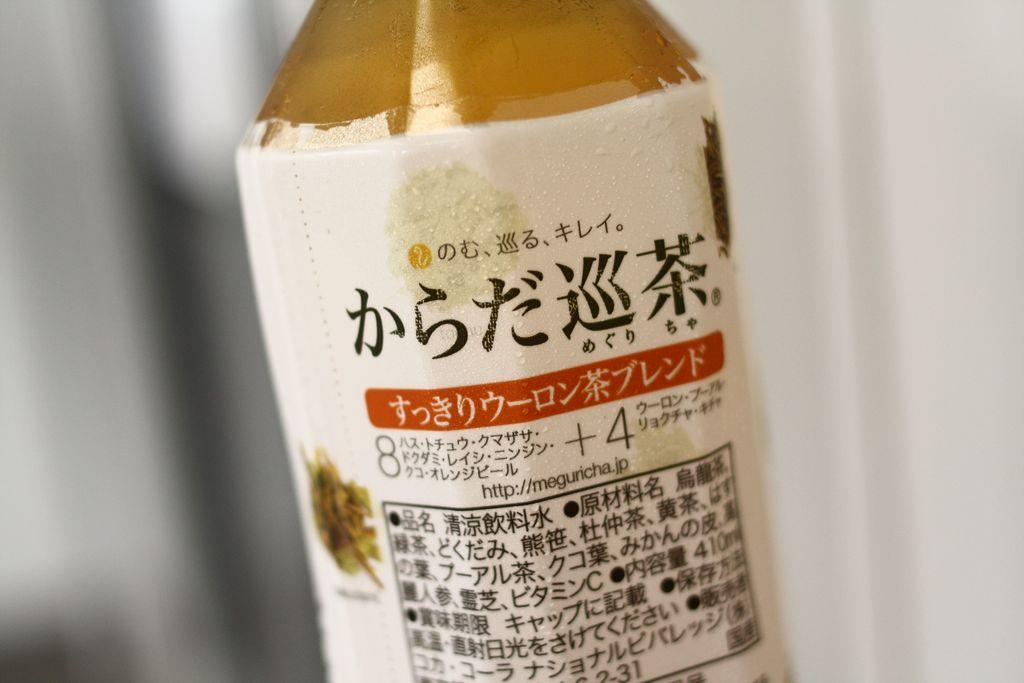What object can be seen in the image? There is a bottle in the image. What is featured on the bottle? There is written text on the bottle. Are there any toys visible in the image? There is no mention of toys in the image, so we cannot confirm their presence. 